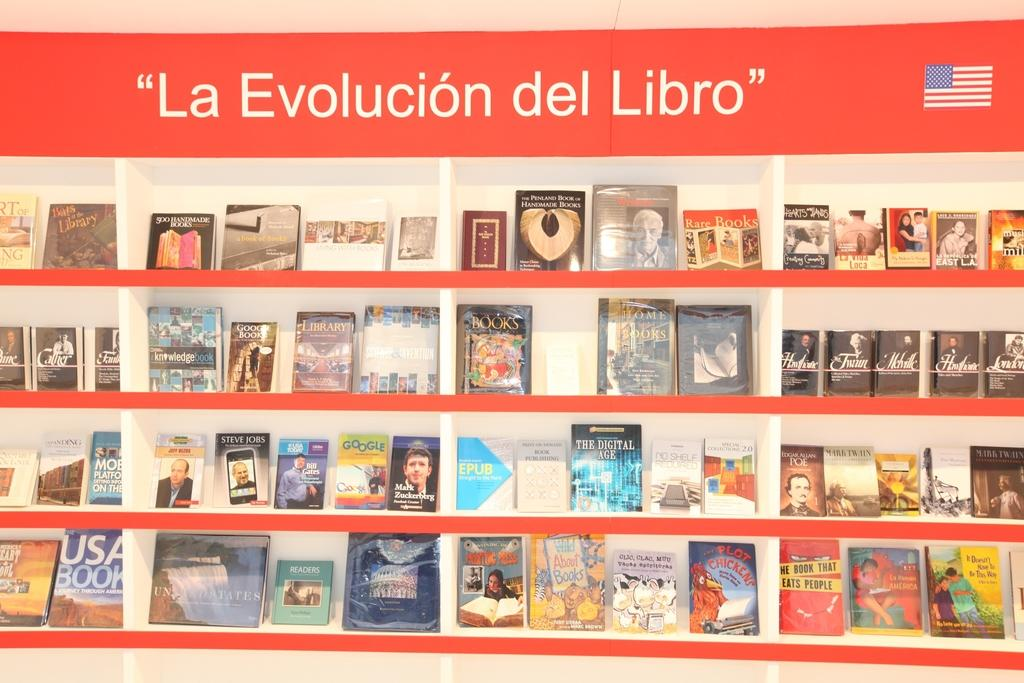Provide a one-sentence caption for the provided image. A display of books is captioned "la evolucion del libro.". 